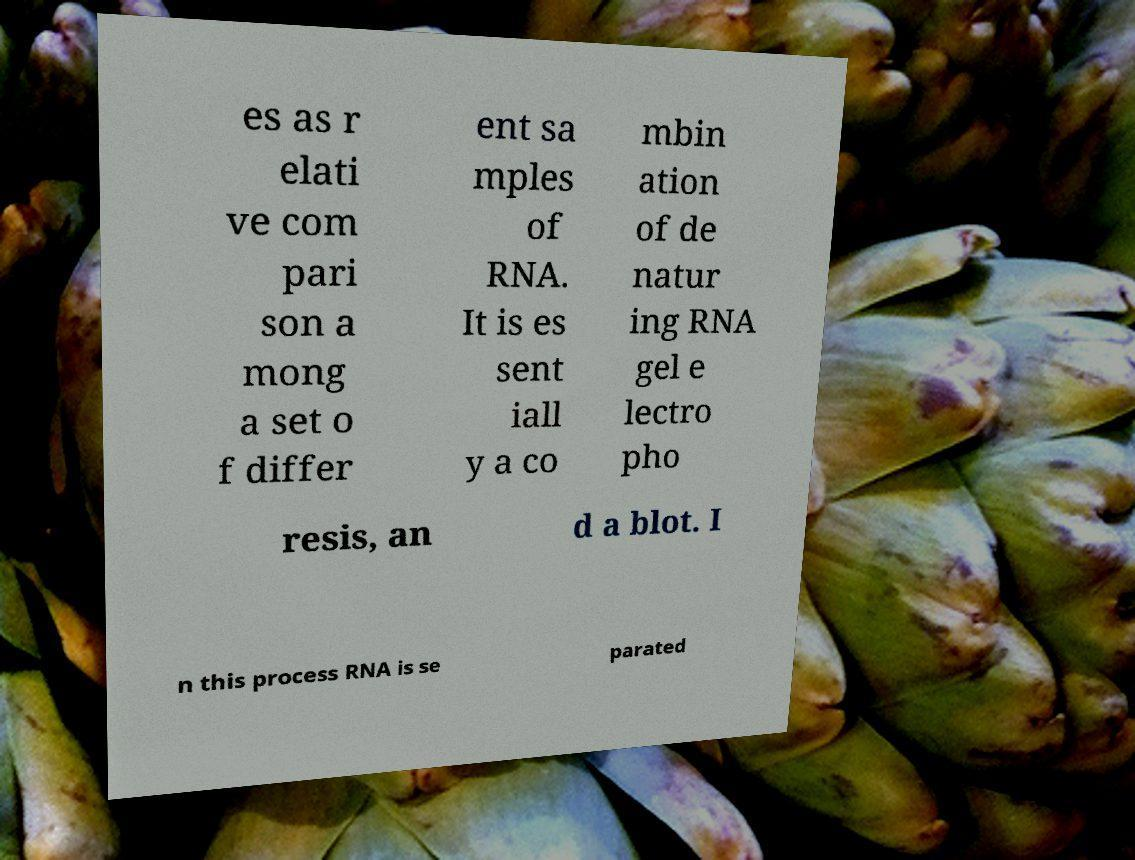What messages or text are displayed in this image? I need them in a readable, typed format. es as r elati ve com pari son a mong a set o f differ ent sa mples of RNA. It is es sent iall y a co mbin ation of de natur ing RNA gel e lectro pho resis, an d a blot. I n this process RNA is se parated 